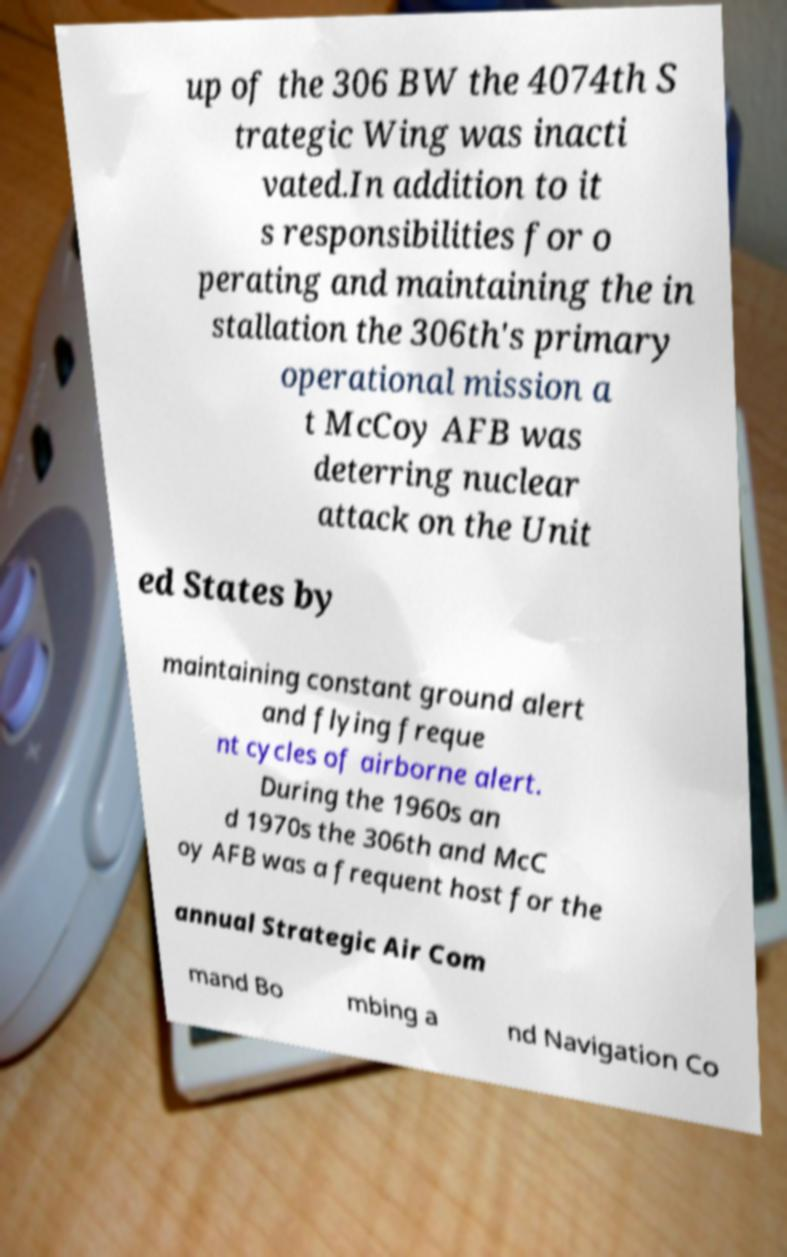Please read and relay the text visible in this image. What does it say? up of the 306 BW the 4074th S trategic Wing was inacti vated.In addition to it s responsibilities for o perating and maintaining the in stallation the 306th's primary operational mission a t McCoy AFB was deterring nuclear attack on the Unit ed States by maintaining constant ground alert and flying freque nt cycles of airborne alert. During the 1960s an d 1970s the 306th and McC oy AFB was a frequent host for the annual Strategic Air Com mand Bo mbing a nd Navigation Co 